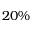<formula> <loc_0><loc_0><loc_500><loc_500>2 0 \%</formula> 